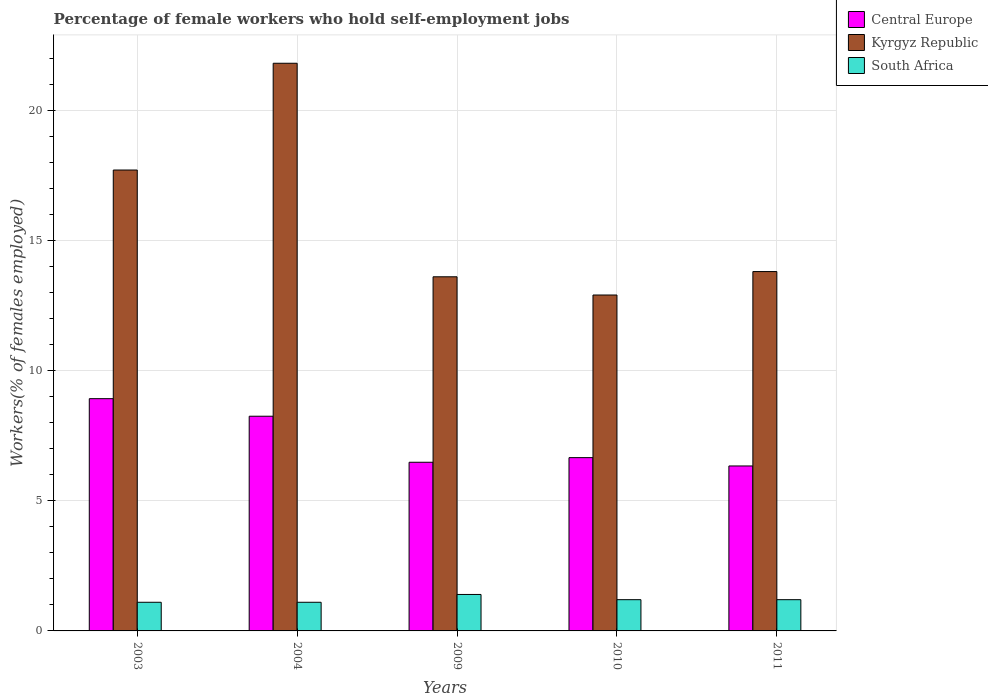How many groups of bars are there?
Make the answer very short. 5. Are the number of bars per tick equal to the number of legend labels?
Offer a very short reply. Yes. How many bars are there on the 5th tick from the left?
Your answer should be compact. 3. What is the percentage of self-employed female workers in Kyrgyz Republic in 2010?
Your answer should be compact. 12.9. Across all years, what is the maximum percentage of self-employed female workers in Central Europe?
Offer a terse response. 8.92. Across all years, what is the minimum percentage of self-employed female workers in South Africa?
Your answer should be compact. 1.1. In which year was the percentage of self-employed female workers in Central Europe minimum?
Offer a terse response. 2011. What is the total percentage of self-employed female workers in South Africa in the graph?
Your answer should be compact. 6. What is the difference between the percentage of self-employed female workers in Kyrgyz Republic in 2004 and that in 2010?
Offer a terse response. 8.9. What is the difference between the percentage of self-employed female workers in Central Europe in 2010 and the percentage of self-employed female workers in Kyrgyz Republic in 2003?
Provide a succinct answer. -11.05. What is the average percentage of self-employed female workers in Kyrgyz Republic per year?
Make the answer very short. 15.96. In the year 2011, what is the difference between the percentage of self-employed female workers in Central Europe and percentage of self-employed female workers in South Africa?
Offer a very short reply. 5.13. What is the ratio of the percentage of self-employed female workers in South Africa in 2004 to that in 2009?
Offer a terse response. 0.79. What is the difference between the highest and the second highest percentage of self-employed female workers in South Africa?
Ensure brevity in your answer.  0.2. What is the difference between the highest and the lowest percentage of self-employed female workers in South Africa?
Make the answer very short. 0.3. In how many years, is the percentage of self-employed female workers in Kyrgyz Republic greater than the average percentage of self-employed female workers in Kyrgyz Republic taken over all years?
Provide a succinct answer. 2. What does the 1st bar from the left in 2004 represents?
Provide a short and direct response. Central Europe. What does the 1st bar from the right in 2009 represents?
Provide a succinct answer. South Africa. Is it the case that in every year, the sum of the percentage of self-employed female workers in South Africa and percentage of self-employed female workers in Central Europe is greater than the percentage of self-employed female workers in Kyrgyz Republic?
Your answer should be very brief. No. How many bars are there?
Offer a very short reply. 15. What is the difference between two consecutive major ticks on the Y-axis?
Offer a terse response. 5. Are the values on the major ticks of Y-axis written in scientific E-notation?
Your answer should be very brief. No. Does the graph contain grids?
Ensure brevity in your answer.  Yes. How are the legend labels stacked?
Provide a succinct answer. Vertical. What is the title of the graph?
Offer a terse response. Percentage of female workers who hold self-employment jobs. What is the label or title of the Y-axis?
Ensure brevity in your answer.  Workers(% of females employed). What is the Workers(% of females employed) in Central Europe in 2003?
Give a very brief answer. 8.92. What is the Workers(% of females employed) in Kyrgyz Republic in 2003?
Your response must be concise. 17.7. What is the Workers(% of females employed) in South Africa in 2003?
Keep it short and to the point. 1.1. What is the Workers(% of females employed) in Central Europe in 2004?
Your response must be concise. 8.24. What is the Workers(% of females employed) of Kyrgyz Republic in 2004?
Keep it short and to the point. 21.8. What is the Workers(% of females employed) of South Africa in 2004?
Your response must be concise. 1.1. What is the Workers(% of females employed) in Central Europe in 2009?
Make the answer very short. 6.48. What is the Workers(% of females employed) of Kyrgyz Republic in 2009?
Your response must be concise. 13.6. What is the Workers(% of females employed) of South Africa in 2009?
Provide a succinct answer. 1.4. What is the Workers(% of females employed) of Central Europe in 2010?
Provide a short and direct response. 6.65. What is the Workers(% of females employed) in Kyrgyz Republic in 2010?
Offer a very short reply. 12.9. What is the Workers(% of females employed) in South Africa in 2010?
Provide a succinct answer. 1.2. What is the Workers(% of females employed) of Central Europe in 2011?
Your answer should be very brief. 6.33. What is the Workers(% of females employed) in Kyrgyz Republic in 2011?
Give a very brief answer. 13.8. What is the Workers(% of females employed) in South Africa in 2011?
Your response must be concise. 1.2. Across all years, what is the maximum Workers(% of females employed) in Central Europe?
Offer a very short reply. 8.92. Across all years, what is the maximum Workers(% of females employed) in Kyrgyz Republic?
Provide a short and direct response. 21.8. Across all years, what is the maximum Workers(% of females employed) in South Africa?
Your response must be concise. 1.4. Across all years, what is the minimum Workers(% of females employed) of Central Europe?
Your answer should be very brief. 6.33. Across all years, what is the minimum Workers(% of females employed) in Kyrgyz Republic?
Offer a terse response. 12.9. Across all years, what is the minimum Workers(% of females employed) of South Africa?
Offer a very short reply. 1.1. What is the total Workers(% of females employed) in Central Europe in the graph?
Make the answer very short. 36.63. What is the total Workers(% of females employed) of Kyrgyz Republic in the graph?
Offer a very short reply. 79.8. What is the total Workers(% of females employed) in South Africa in the graph?
Ensure brevity in your answer.  6. What is the difference between the Workers(% of females employed) in Central Europe in 2003 and that in 2004?
Your answer should be compact. 0.67. What is the difference between the Workers(% of females employed) in South Africa in 2003 and that in 2004?
Ensure brevity in your answer.  0. What is the difference between the Workers(% of females employed) in Central Europe in 2003 and that in 2009?
Ensure brevity in your answer.  2.44. What is the difference between the Workers(% of females employed) in Kyrgyz Republic in 2003 and that in 2009?
Your answer should be very brief. 4.1. What is the difference between the Workers(% of females employed) of South Africa in 2003 and that in 2009?
Your answer should be very brief. -0.3. What is the difference between the Workers(% of females employed) in Central Europe in 2003 and that in 2010?
Ensure brevity in your answer.  2.26. What is the difference between the Workers(% of females employed) of Central Europe in 2003 and that in 2011?
Offer a terse response. 2.58. What is the difference between the Workers(% of females employed) of Kyrgyz Republic in 2003 and that in 2011?
Give a very brief answer. 3.9. What is the difference between the Workers(% of females employed) of South Africa in 2003 and that in 2011?
Your response must be concise. -0.1. What is the difference between the Workers(% of females employed) of Central Europe in 2004 and that in 2009?
Make the answer very short. 1.77. What is the difference between the Workers(% of females employed) in South Africa in 2004 and that in 2009?
Your response must be concise. -0.3. What is the difference between the Workers(% of females employed) of Central Europe in 2004 and that in 2010?
Offer a terse response. 1.59. What is the difference between the Workers(% of females employed) in Kyrgyz Republic in 2004 and that in 2010?
Keep it short and to the point. 8.9. What is the difference between the Workers(% of females employed) of Central Europe in 2004 and that in 2011?
Make the answer very short. 1.91. What is the difference between the Workers(% of females employed) in Kyrgyz Republic in 2004 and that in 2011?
Keep it short and to the point. 8. What is the difference between the Workers(% of females employed) in South Africa in 2004 and that in 2011?
Your answer should be compact. -0.1. What is the difference between the Workers(% of females employed) of Central Europe in 2009 and that in 2010?
Ensure brevity in your answer.  -0.18. What is the difference between the Workers(% of females employed) in Central Europe in 2009 and that in 2011?
Ensure brevity in your answer.  0.14. What is the difference between the Workers(% of females employed) of Kyrgyz Republic in 2009 and that in 2011?
Provide a short and direct response. -0.2. What is the difference between the Workers(% of females employed) of Central Europe in 2010 and that in 2011?
Provide a short and direct response. 0.32. What is the difference between the Workers(% of females employed) of South Africa in 2010 and that in 2011?
Offer a very short reply. 0. What is the difference between the Workers(% of females employed) of Central Europe in 2003 and the Workers(% of females employed) of Kyrgyz Republic in 2004?
Ensure brevity in your answer.  -12.88. What is the difference between the Workers(% of females employed) in Central Europe in 2003 and the Workers(% of females employed) in South Africa in 2004?
Offer a very short reply. 7.82. What is the difference between the Workers(% of females employed) in Central Europe in 2003 and the Workers(% of females employed) in Kyrgyz Republic in 2009?
Give a very brief answer. -4.68. What is the difference between the Workers(% of females employed) of Central Europe in 2003 and the Workers(% of females employed) of South Africa in 2009?
Provide a succinct answer. 7.52. What is the difference between the Workers(% of females employed) in Central Europe in 2003 and the Workers(% of females employed) in Kyrgyz Republic in 2010?
Give a very brief answer. -3.98. What is the difference between the Workers(% of females employed) in Central Europe in 2003 and the Workers(% of females employed) in South Africa in 2010?
Your answer should be compact. 7.72. What is the difference between the Workers(% of females employed) in Kyrgyz Republic in 2003 and the Workers(% of females employed) in South Africa in 2010?
Your response must be concise. 16.5. What is the difference between the Workers(% of females employed) in Central Europe in 2003 and the Workers(% of females employed) in Kyrgyz Republic in 2011?
Keep it short and to the point. -4.88. What is the difference between the Workers(% of females employed) in Central Europe in 2003 and the Workers(% of females employed) in South Africa in 2011?
Ensure brevity in your answer.  7.72. What is the difference between the Workers(% of females employed) of Central Europe in 2004 and the Workers(% of females employed) of Kyrgyz Republic in 2009?
Your response must be concise. -5.36. What is the difference between the Workers(% of females employed) in Central Europe in 2004 and the Workers(% of females employed) in South Africa in 2009?
Offer a very short reply. 6.84. What is the difference between the Workers(% of females employed) of Kyrgyz Republic in 2004 and the Workers(% of females employed) of South Africa in 2009?
Offer a very short reply. 20.4. What is the difference between the Workers(% of females employed) in Central Europe in 2004 and the Workers(% of females employed) in Kyrgyz Republic in 2010?
Give a very brief answer. -4.66. What is the difference between the Workers(% of females employed) of Central Europe in 2004 and the Workers(% of females employed) of South Africa in 2010?
Ensure brevity in your answer.  7.04. What is the difference between the Workers(% of females employed) in Kyrgyz Republic in 2004 and the Workers(% of females employed) in South Africa in 2010?
Your answer should be compact. 20.6. What is the difference between the Workers(% of females employed) in Central Europe in 2004 and the Workers(% of females employed) in Kyrgyz Republic in 2011?
Give a very brief answer. -5.56. What is the difference between the Workers(% of females employed) of Central Europe in 2004 and the Workers(% of females employed) of South Africa in 2011?
Your answer should be very brief. 7.04. What is the difference between the Workers(% of females employed) in Kyrgyz Republic in 2004 and the Workers(% of females employed) in South Africa in 2011?
Provide a succinct answer. 20.6. What is the difference between the Workers(% of females employed) of Central Europe in 2009 and the Workers(% of females employed) of Kyrgyz Republic in 2010?
Make the answer very short. -6.42. What is the difference between the Workers(% of females employed) of Central Europe in 2009 and the Workers(% of females employed) of South Africa in 2010?
Keep it short and to the point. 5.28. What is the difference between the Workers(% of females employed) in Central Europe in 2009 and the Workers(% of females employed) in Kyrgyz Republic in 2011?
Keep it short and to the point. -7.32. What is the difference between the Workers(% of females employed) in Central Europe in 2009 and the Workers(% of females employed) in South Africa in 2011?
Keep it short and to the point. 5.28. What is the difference between the Workers(% of females employed) of Kyrgyz Republic in 2009 and the Workers(% of females employed) of South Africa in 2011?
Your response must be concise. 12.4. What is the difference between the Workers(% of females employed) of Central Europe in 2010 and the Workers(% of females employed) of Kyrgyz Republic in 2011?
Offer a terse response. -7.15. What is the difference between the Workers(% of females employed) in Central Europe in 2010 and the Workers(% of females employed) in South Africa in 2011?
Keep it short and to the point. 5.45. What is the difference between the Workers(% of females employed) of Kyrgyz Republic in 2010 and the Workers(% of females employed) of South Africa in 2011?
Make the answer very short. 11.7. What is the average Workers(% of females employed) of Central Europe per year?
Your response must be concise. 7.33. What is the average Workers(% of females employed) in Kyrgyz Republic per year?
Your answer should be very brief. 15.96. In the year 2003, what is the difference between the Workers(% of females employed) in Central Europe and Workers(% of females employed) in Kyrgyz Republic?
Keep it short and to the point. -8.78. In the year 2003, what is the difference between the Workers(% of females employed) of Central Europe and Workers(% of females employed) of South Africa?
Offer a terse response. 7.82. In the year 2004, what is the difference between the Workers(% of females employed) in Central Europe and Workers(% of females employed) in Kyrgyz Republic?
Your response must be concise. -13.56. In the year 2004, what is the difference between the Workers(% of females employed) of Central Europe and Workers(% of females employed) of South Africa?
Give a very brief answer. 7.14. In the year 2004, what is the difference between the Workers(% of females employed) in Kyrgyz Republic and Workers(% of females employed) in South Africa?
Ensure brevity in your answer.  20.7. In the year 2009, what is the difference between the Workers(% of females employed) of Central Europe and Workers(% of females employed) of Kyrgyz Republic?
Keep it short and to the point. -7.12. In the year 2009, what is the difference between the Workers(% of females employed) in Central Europe and Workers(% of females employed) in South Africa?
Your answer should be compact. 5.08. In the year 2010, what is the difference between the Workers(% of females employed) of Central Europe and Workers(% of females employed) of Kyrgyz Republic?
Your response must be concise. -6.25. In the year 2010, what is the difference between the Workers(% of females employed) of Central Europe and Workers(% of females employed) of South Africa?
Give a very brief answer. 5.45. In the year 2011, what is the difference between the Workers(% of females employed) of Central Europe and Workers(% of females employed) of Kyrgyz Republic?
Offer a very short reply. -7.47. In the year 2011, what is the difference between the Workers(% of females employed) of Central Europe and Workers(% of females employed) of South Africa?
Offer a terse response. 5.13. In the year 2011, what is the difference between the Workers(% of females employed) in Kyrgyz Republic and Workers(% of females employed) in South Africa?
Provide a short and direct response. 12.6. What is the ratio of the Workers(% of females employed) of Central Europe in 2003 to that in 2004?
Offer a very short reply. 1.08. What is the ratio of the Workers(% of females employed) in Kyrgyz Republic in 2003 to that in 2004?
Ensure brevity in your answer.  0.81. What is the ratio of the Workers(% of females employed) in South Africa in 2003 to that in 2004?
Offer a terse response. 1. What is the ratio of the Workers(% of females employed) in Central Europe in 2003 to that in 2009?
Provide a short and direct response. 1.38. What is the ratio of the Workers(% of females employed) in Kyrgyz Republic in 2003 to that in 2009?
Provide a short and direct response. 1.3. What is the ratio of the Workers(% of females employed) in South Africa in 2003 to that in 2009?
Your answer should be compact. 0.79. What is the ratio of the Workers(% of females employed) in Central Europe in 2003 to that in 2010?
Your answer should be very brief. 1.34. What is the ratio of the Workers(% of females employed) in Kyrgyz Republic in 2003 to that in 2010?
Make the answer very short. 1.37. What is the ratio of the Workers(% of females employed) of South Africa in 2003 to that in 2010?
Ensure brevity in your answer.  0.92. What is the ratio of the Workers(% of females employed) of Central Europe in 2003 to that in 2011?
Give a very brief answer. 1.41. What is the ratio of the Workers(% of females employed) of Kyrgyz Republic in 2003 to that in 2011?
Provide a short and direct response. 1.28. What is the ratio of the Workers(% of females employed) of South Africa in 2003 to that in 2011?
Give a very brief answer. 0.92. What is the ratio of the Workers(% of females employed) in Central Europe in 2004 to that in 2009?
Give a very brief answer. 1.27. What is the ratio of the Workers(% of females employed) in Kyrgyz Republic in 2004 to that in 2009?
Give a very brief answer. 1.6. What is the ratio of the Workers(% of females employed) of South Africa in 2004 to that in 2009?
Your answer should be very brief. 0.79. What is the ratio of the Workers(% of females employed) in Central Europe in 2004 to that in 2010?
Make the answer very short. 1.24. What is the ratio of the Workers(% of females employed) in Kyrgyz Republic in 2004 to that in 2010?
Provide a short and direct response. 1.69. What is the ratio of the Workers(% of females employed) in Central Europe in 2004 to that in 2011?
Keep it short and to the point. 1.3. What is the ratio of the Workers(% of females employed) in Kyrgyz Republic in 2004 to that in 2011?
Ensure brevity in your answer.  1.58. What is the ratio of the Workers(% of females employed) in Central Europe in 2009 to that in 2010?
Offer a very short reply. 0.97. What is the ratio of the Workers(% of females employed) of Kyrgyz Republic in 2009 to that in 2010?
Your answer should be compact. 1.05. What is the ratio of the Workers(% of females employed) in Central Europe in 2009 to that in 2011?
Offer a very short reply. 1.02. What is the ratio of the Workers(% of females employed) in Kyrgyz Republic in 2009 to that in 2011?
Give a very brief answer. 0.99. What is the ratio of the Workers(% of females employed) of Central Europe in 2010 to that in 2011?
Your answer should be compact. 1.05. What is the ratio of the Workers(% of females employed) in Kyrgyz Republic in 2010 to that in 2011?
Offer a terse response. 0.93. What is the difference between the highest and the second highest Workers(% of females employed) of Central Europe?
Your answer should be very brief. 0.67. What is the difference between the highest and the second highest Workers(% of females employed) in Kyrgyz Republic?
Your response must be concise. 4.1. What is the difference between the highest and the second highest Workers(% of females employed) of South Africa?
Your response must be concise. 0.2. What is the difference between the highest and the lowest Workers(% of females employed) in Central Europe?
Offer a terse response. 2.58. What is the difference between the highest and the lowest Workers(% of females employed) in Kyrgyz Republic?
Keep it short and to the point. 8.9. 